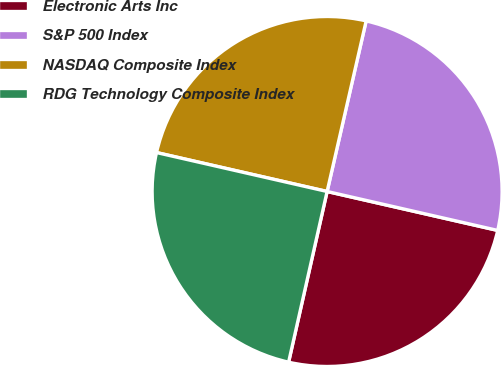Convert chart. <chart><loc_0><loc_0><loc_500><loc_500><pie_chart><fcel>Electronic Arts Inc<fcel>S&P 500 Index<fcel>NASDAQ Composite Index<fcel>RDG Technology Composite Index<nl><fcel>24.96%<fcel>24.99%<fcel>25.01%<fcel>25.04%<nl></chart> 